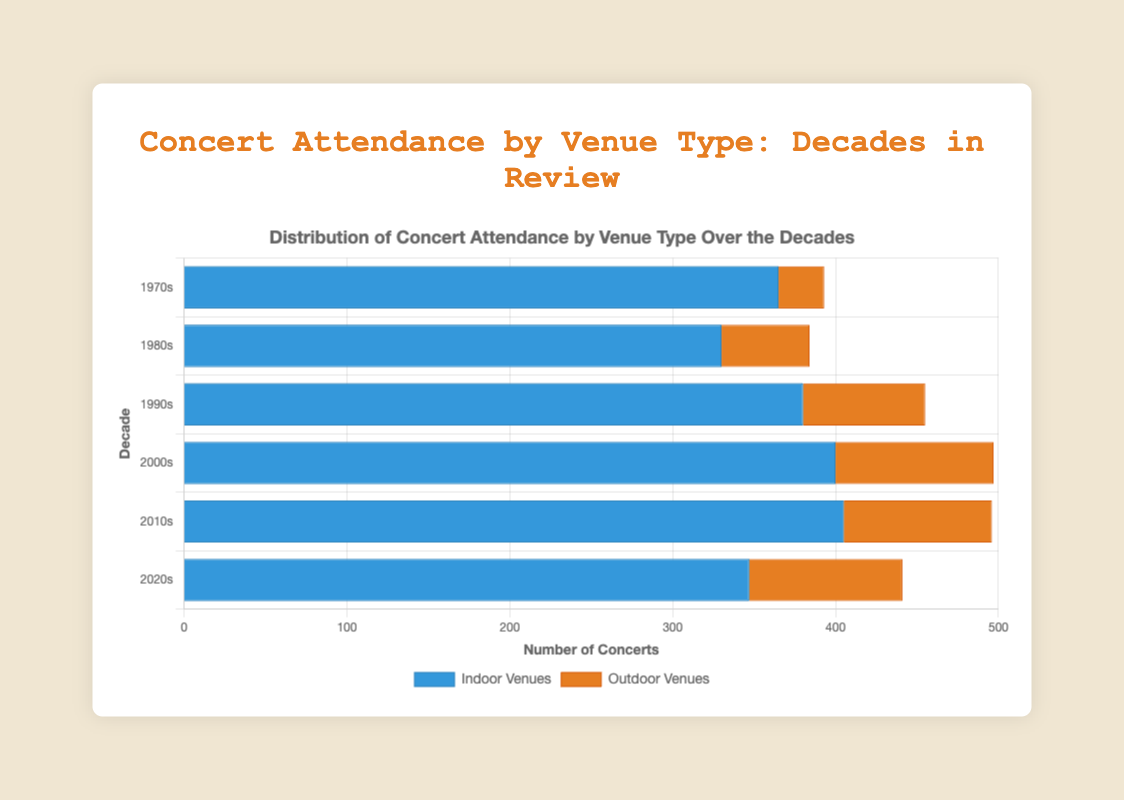How did the total number of concerts at indoor venues change from the 1970s to the 2010s? To determine this, sum the number of concerts at indoor venues for the 1970s (120 + 85 + 95 + 65 = 365) and for the 2010s (150 + 100 + 90 + 65 = 405). Compare these sums: 405 (2010s) - 365 (1970s) = 40.
Answer: Increased by 40 Are there more concerts held in outdoor venues in the 1980s or the 2000s? For the 1980s, sum the concerts at outdoor venues (6 + 20 + 13 + 15 = 54). For the 2000s, sum the concerts at outdoor venues (22 + 18 + 30 + 27 = 97). Compare the sums: 54 (1980s) versus 97 (2000s).
Answer: 2000s Which decade had the highest number of concerts at indoor venues? Sum the number of indoor concerts for each decade and compare: 1970s (365), 1980s (330), 1990s (380), 2000s (400), 2010s (405), 2020s (347). The highest value is 405.
Answer: 2010s What is the difference in the number of outdoor concerts between the 1990s and the 2020s? Calculate the total for outdoor venues in the 1990s (18 + 22 + 25 + 10 = 75) and in the 2020s (33 + 22 + 19 + 20 = 94), then find the difference: 94 - 75 = 19.
Answer: 19 How many more concerts were held at indoor venues compared to outdoor venues in the 2000s? Sum the indoor concerts in the 2000s (145 + 95 + 85 + 75 = 400) and the outdoor concerts (22 + 18 + 30 + 27 = 97), then find the difference: 400 - 97 = 303.
Answer: 303 Which venue had the most concerts in the 2010s? Looking at the data for the 2010s, Barclays Center had the most indoor concerts (150) and Red Rocks Amphitheatre had the most outdoor concerts (29). Comparing these values, 150 is higher.
Answer: Barclays Center What percentage of total concerts in the 1980s occurred at outdoor venues? First, sum all concerts in the 1980s (indoors: 110 + 90 + 70 + 60 = 330; outdoors: 6 + 20 + 13 + 15 = 54; total: 330 + 54 = 384). Then calculate the percentage: (54/384) * 100 ≈ 14.06%.
Answer: 14.06% What is the total number of concerts held at Madison Square Garden from the 1970s to the 1990s? Sum the concerts at Madison Square Garden from the 1970s (120) and the 1990s (130). The total is 120 + 130 = 250.
Answer: 250 Which decade shows the smallest difference between concerts held at indoor and outdoor venues? Calculate differences by decade: 1970s: 365 - 28 = 337, 1980s: 330 - 54 = 276, 1990s: 380 - 75 = 305, 2000s: 400 - 97 = 303, 2010s: 405 - 91 = 314, 2020s: 347 - 94 = 253. The smallest difference is 253.
Answer: 2020s Which venue held the highest number of concerts in any decade, and how many? Identify the venue with the highest number in any decade. Barclays Center in the 2010s hosted 150 concerts, the highest count.
Answer: Barclays Center, 150 